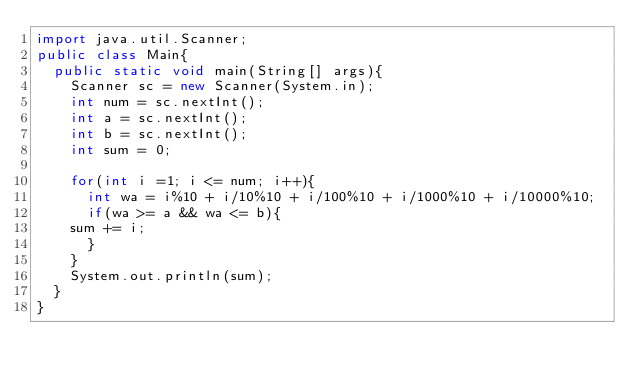Convert code to text. <code><loc_0><loc_0><loc_500><loc_500><_Java_>import java.util.Scanner;
public class Main{
  public static void main(String[] args){
    Scanner sc = new Scanner(System.in);
    int num = sc.nextInt();
    int a = sc.nextInt();
    int b = sc.nextInt();
    int sum = 0;
    
    for(int i =1; i <= num; i++){
      int wa = i%10 + i/10%10 + i/100%10 + i/1000%10 + i/10000%10;
      if(wa >= a && wa <= b){
		sum += i;
      }
    }  
    System.out.println(sum);
  }
}</code> 